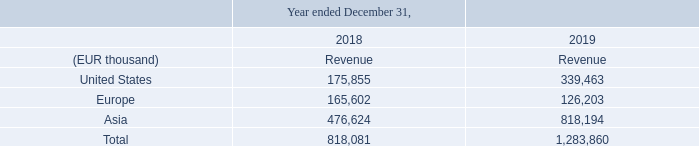NOTE 21. REVENUE
Geographical information is summarized as follows:
For geographical reporting, the revenue is attributed to the geographical location in which the customer’s facilities are located.
How is revenue attributed in geographical reporting? Attributed to the geographical location in which the customer’s facilities are located. What years does the table provide Geographical information for? 2018, 2019. What are the regions presented in the table? United states, europe, asia. What was the percentage change in revenue from 2018 to 2019?
Answer scale should be: percent.  (1,283,860 - 818,081 )/ 818,081
Answer: 56.94. What are the regions ranked in descending order in terms of revenue for 2019? Sort the values and corresponding regions in COL2 in COL4 row 4-6 in descending order by the values in COL4
Answer: asia, united states, europe. Which region had the largest percentage change in revenue from 2018 to 2019? United States:((339,463-175,855)/175,855=0.93)  Europe :((126,203-165,602)/165,602=-0.24)  Asia:( (818,194 -476,624)/476,624=0.72)
Answer: united states. 